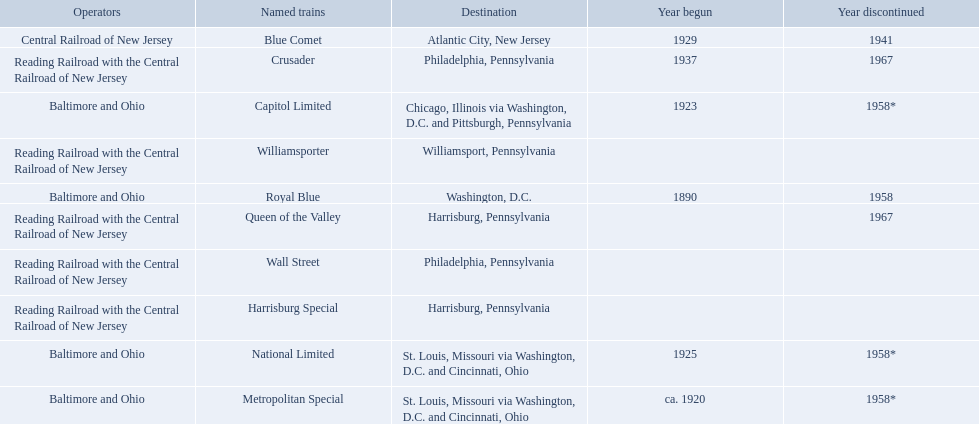What destinations are listed from the central railroad of new jersey terminal? Chicago, Illinois via Washington, D.C. and Pittsburgh, Pennsylvania, St. Louis, Missouri via Washington, D.C. and Cincinnati, Ohio, St. Louis, Missouri via Washington, D.C. and Cincinnati, Ohio, Washington, D.C., Atlantic City, New Jersey, Philadelphia, Pennsylvania, Harrisburg, Pennsylvania, Harrisburg, Pennsylvania, Philadelphia, Pennsylvania, Williamsport, Pennsylvania. Which of these destinations is listed first? Chicago, Illinois via Washington, D.C. and Pittsburgh, Pennsylvania. Which operators are the reading railroad with the central railroad of new jersey? Reading Railroad with the Central Railroad of New Jersey, Reading Railroad with the Central Railroad of New Jersey, Reading Railroad with the Central Railroad of New Jersey, Reading Railroad with the Central Railroad of New Jersey, Reading Railroad with the Central Railroad of New Jersey. Which destinations are philadelphia, pennsylvania? Philadelphia, Pennsylvania, Philadelphia, Pennsylvania. What on began in 1937? 1937. What is the named train? Crusader. 